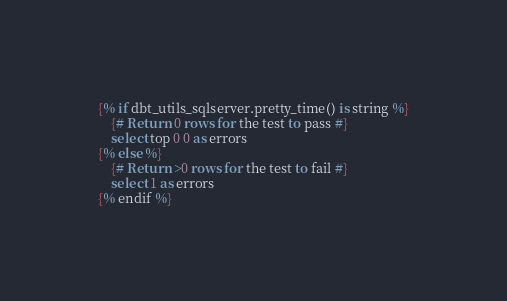<code> <loc_0><loc_0><loc_500><loc_500><_SQL_>{% if dbt_utils_sqlserver.pretty_time() is string %}
    {# Return 0 rows for the test to pass #}
    select top 0 0 as errors
{% else %}
    {# Return >0 rows for the test to fail #}
    select 1 as errors
{% endif %}
</code> 